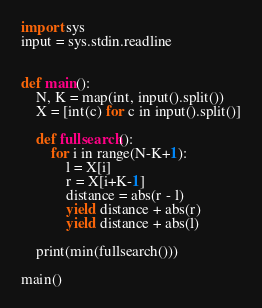Convert code to text. <code><loc_0><loc_0><loc_500><loc_500><_Python_>import sys
input = sys.stdin.readline


def main():
    N, K = map(int, input().split())
    X = [int(c) for c in input().split()]

    def fullsearch():
        for i in range(N-K+1):
            l = X[i]
            r = X[i+K-1]
            distance = abs(r - l)
            yield distance + abs(r)
            yield distance + abs(l)

    print(min(fullsearch()))

main()</code> 